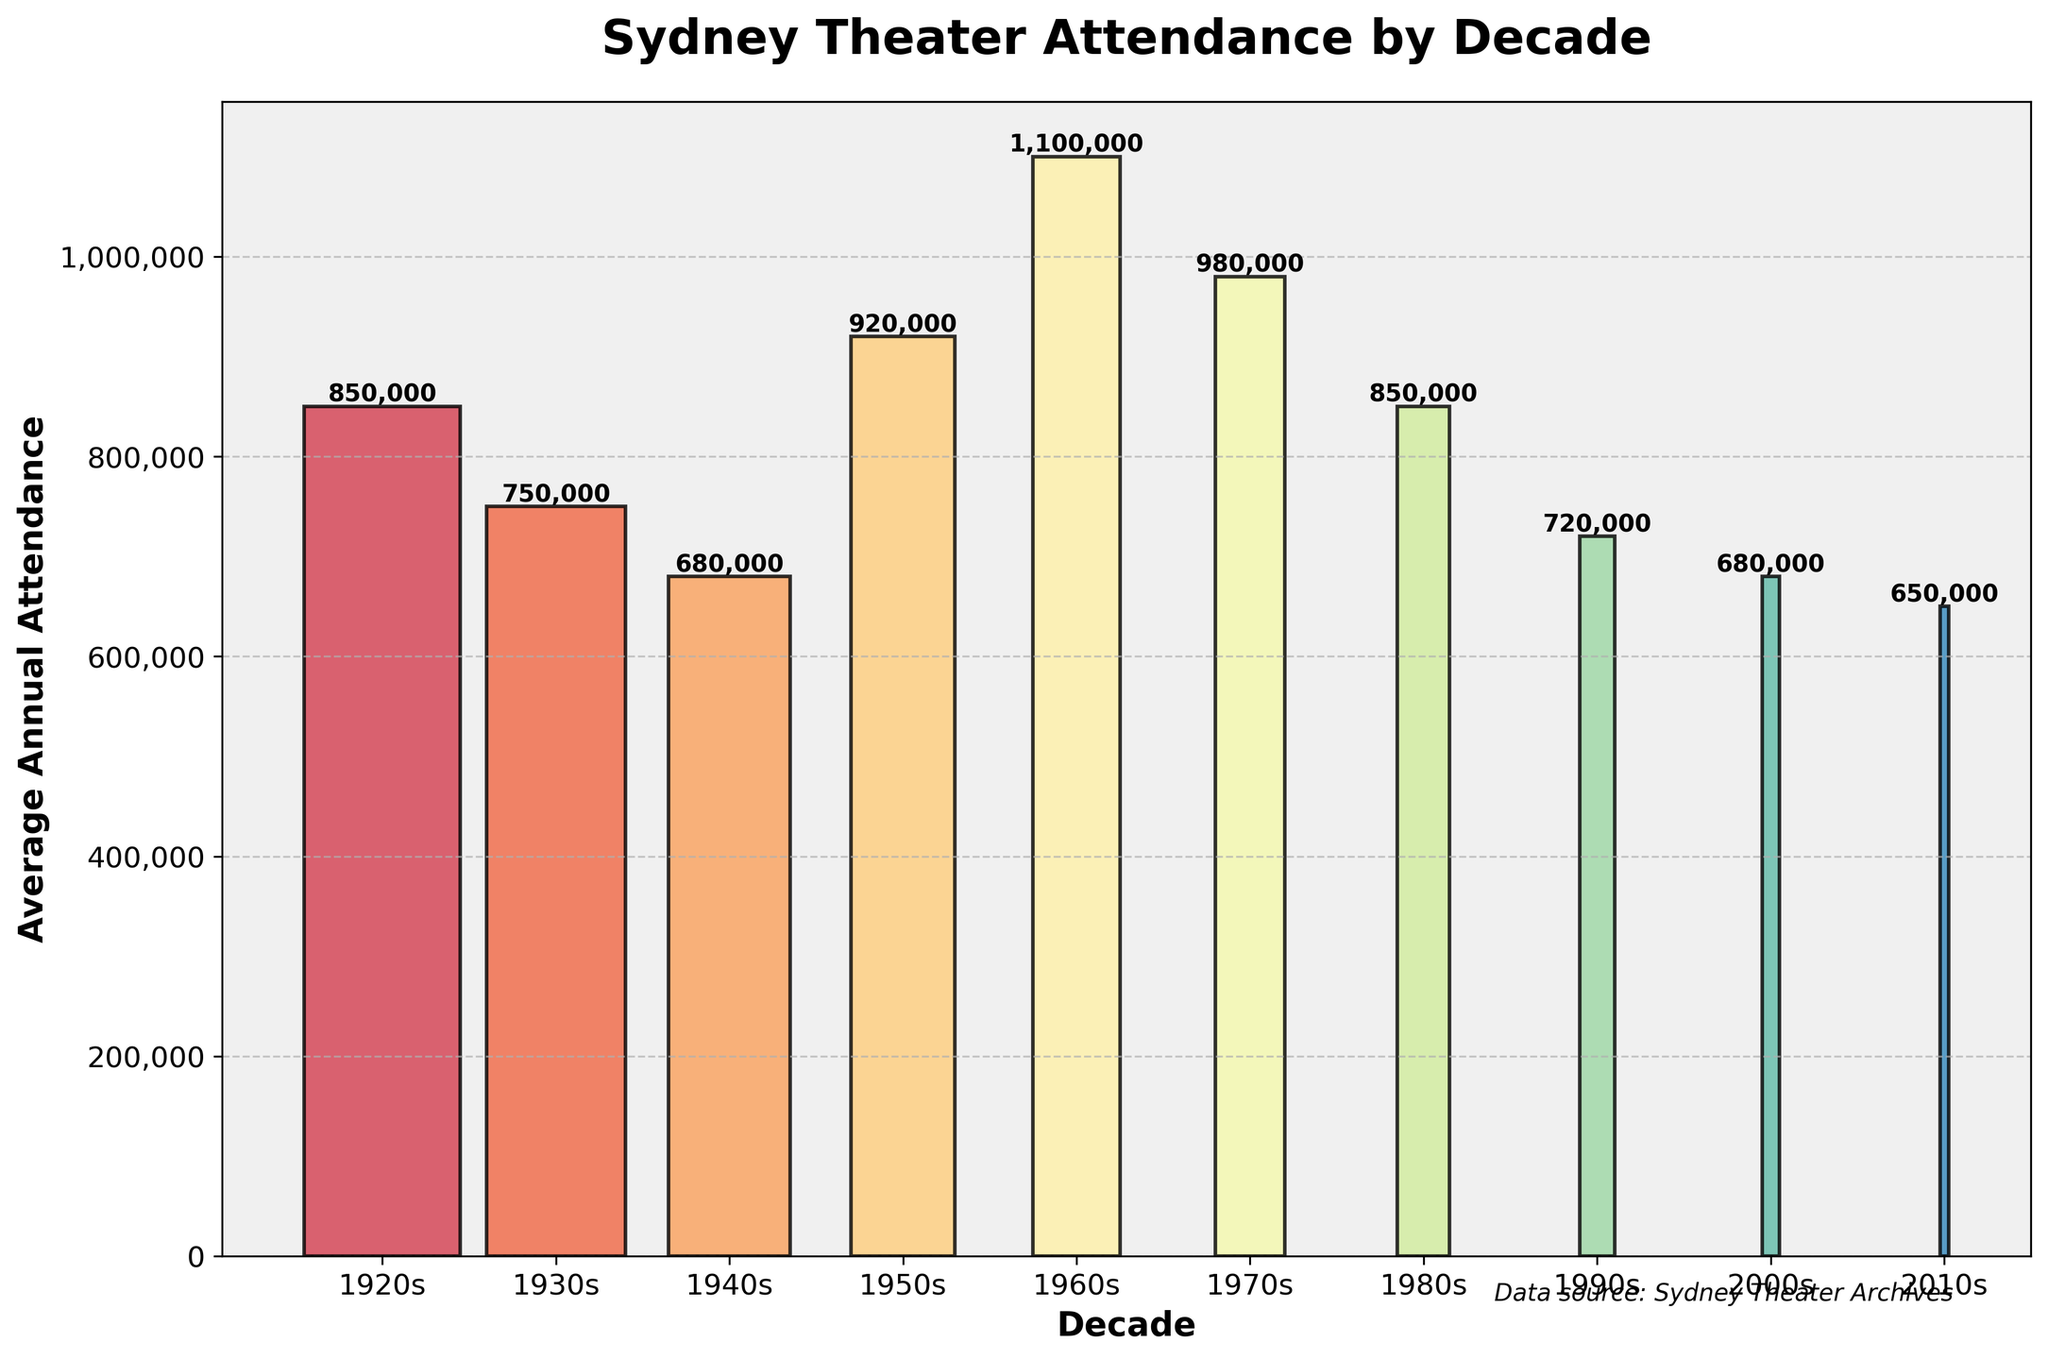What is the title of the funnel chart? The title is displayed at the top of the chart and reads "Sydney Theater Attendance by Decade".
Answer: Sydney Theater Attendance by Decade Which decade had the highest average annual theater attendance in Sydney? The column corresponding to the 1960s is the tallest, indicating the highest average annual attendance.
Answer: 1960s How many decades are shown in the chart? By counting the number of bars or categories on the x-axis, we can see that there are 10 decades displayed.
Answer: 10 What is the average annual theater attendance in Sydney for the 1940s? The bar corresponding to the 1940s has a height indicating an attendance of 680,000.
Answer: 680,000 What is the difference in average annual theater attendance between the 1920s and the 1960s? Subtract the value for the 1920s (850,000) from the value for the 1960s (1,100,000) to find the difference. 1,100,000 - 850,000 = 250,000.
Answer: 250,000 Which decade had a greater drop in average annual theater attendance, the 1980s to 1990s or the 2000s to 2010s? Compare the drop from 850,000 (1980s) to 720,000 (1990s) which is 850,000 - 720,000 = 130,000, to the drop from 680,000 (2000s) to 650,000 (2010s) which is 680,000 - 650,000 = 30,000. The drop is greater between the 1980s and 1990s.
Answer: 1980s to 1990s What is the sum of the average annual theater attendances for the 1950s and 1970s? Add the values for the 1950s (920,000) and the 1970s (980,000). 920,000 + 980,000 = 1,900,000.
Answer: 1,900,000 Which decade experienced a recovery in theater attendance after facing a decline in the prior decade? By looking at the trend, the 1950s show a recovery with an increase to 920,000 after a decline in the 1940s where attendance was 680,000.
Answer: 1950s How does the average annual attendance in the 2000s compare to that in the 1920s? The average annual attendance in the 1920s was 850,000 while it was 680,000 in the 2000s. Thus, the attendance in the 2000s is less than that in the 1920s.
Answer: Less than What pattern is seen in theater attendance from the 1960s to the 2010s? From the highest point in the 1960s, there is a general downward trend in attendance through the 2010s.
Answer: Downward trend 